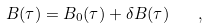<formula> <loc_0><loc_0><loc_500><loc_500>B ( \tau ) = B _ { 0 } ( \tau ) + \delta B ( \tau ) \quad ,</formula> 